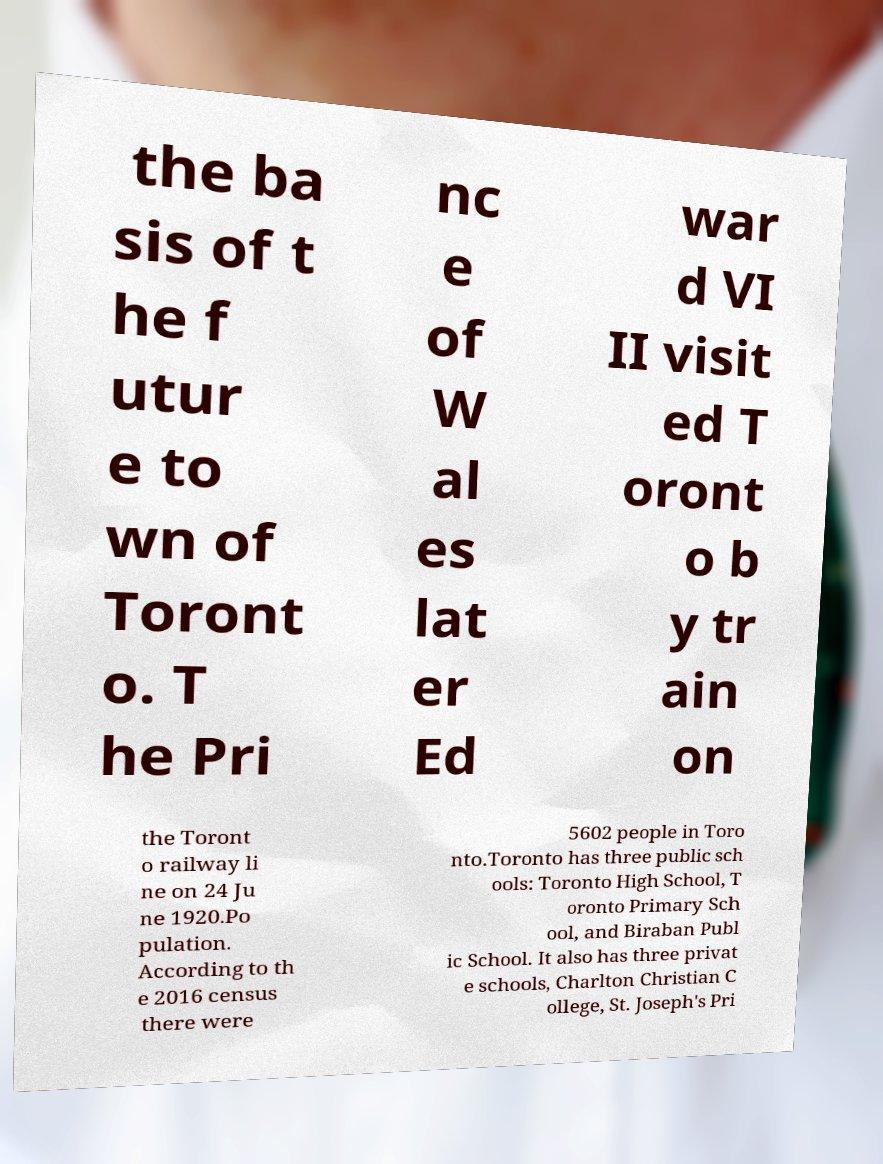Please read and relay the text visible in this image. What does it say? the ba sis of t he f utur e to wn of Toront o. T he Pri nc e of W al es lat er Ed war d VI II visit ed T oront o b y tr ain on the Toront o railway li ne on 24 Ju ne 1920.Po pulation. According to th e 2016 census there were 5602 people in Toro nto.Toronto has three public sch ools: Toronto High School, T oronto Primary Sch ool, and Biraban Publ ic School. It also has three privat e schools, Charlton Christian C ollege, St. Joseph's Pri 